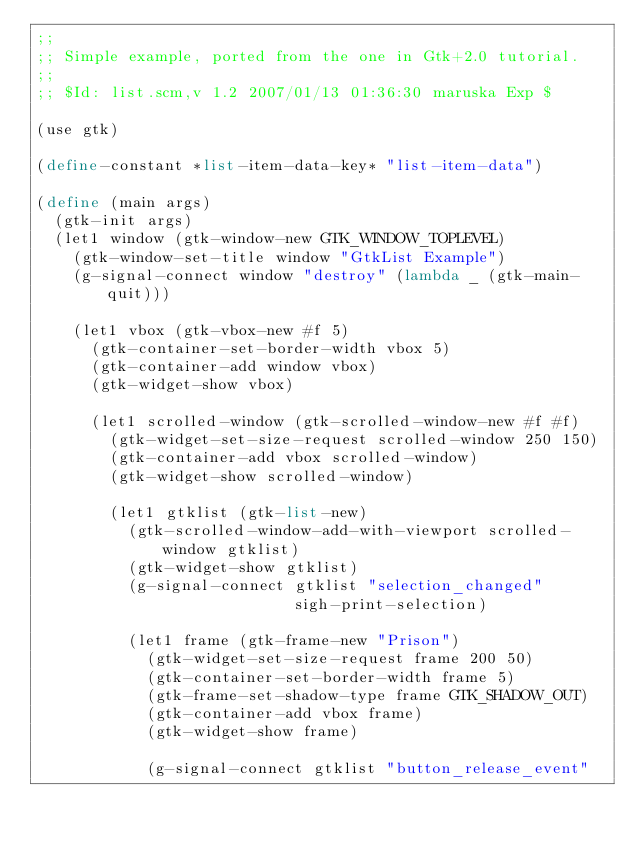<code> <loc_0><loc_0><loc_500><loc_500><_Scheme_>;;
;; Simple example, ported from the one in Gtk+2.0 tutorial.
;;
;; $Id: list.scm,v 1.2 2007/01/13 01:36:30 maruska Exp $

(use gtk)

(define-constant *list-item-data-key* "list-item-data")

(define (main args)
  (gtk-init args)
  (let1 window (gtk-window-new GTK_WINDOW_TOPLEVEL)
    (gtk-window-set-title window "GtkList Example")
    (g-signal-connect window "destroy" (lambda _ (gtk-main-quit)))

    (let1 vbox (gtk-vbox-new #f 5)
      (gtk-container-set-border-width vbox 5)
      (gtk-container-add window vbox)
      (gtk-widget-show vbox)

      (let1 scrolled-window (gtk-scrolled-window-new #f #f)
        (gtk-widget-set-size-request scrolled-window 250 150)
        (gtk-container-add vbox scrolled-window)
        (gtk-widget-show scrolled-window)

        (let1 gtklist (gtk-list-new)
          (gtk-scrolled-window-add-with-viewport scrolled-window gtklist)
          (gtk-widget-show gtklist)
          (g-signal-connect gtklist "selection_changed"
                            sigh-print-selection)
          
          (let1 frame (gtk-frame-new "Prison")
            (gtk-widget-set-size-request frame 200 50)
            (gtk-container-set-border-width frame 5)
            (gtk-frame-set-shadow-type frame GTK_SHADOW_OUT)
            (gtk-container-add vbox frame)
            (gtk-widget-show frame)

            (g-signal-connect gtklist "button_release_event"</code> 